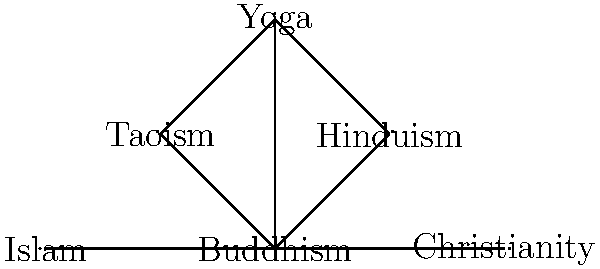In the network diagram representing various spiritual paths, which practice forms the central node connecting all others, and how many direct connections does it have to other spiritual traditions? To answer this question, we need to analyze the network diagram step-by-step:

1. Identify the central node:
   - The node labeled "Buddhism" is at the center of the diagram.
   - It has connections to all other nodes in the network.

2. Count the direct connections from Buddhism:
   - Buddhism is directly connected to Hinduism
   - Buddhism is directly connected to Taoism
   - Buddhism is directly connected to Yoga
   - Buddhism is directly connected to Christianity
   - Buddhism is directly connected to Islam

3. Sum up the total number of direct connections:
   - Buddhism has 5 direct connections to other spiritual traditions.

4. Verify the centrality:
   - No other node in the diagram has as many connections as Buddhism.
   - This confirms that Buddhism is indeed the central node in this representation.

5. Interpret the significance:
   - This diagram suggests that Buddhism shares common elements or influences with various other spiritual traditions.
   - It highlights the interconnectedness of spiritual paths, with Buddhism serving as a bridge between different practices.

Therefore, Buddhism forms the central node in this network representation of spiritual paths, and it has 5 direct connections to other traditions.
Answer: Buddhism, 5 connections 